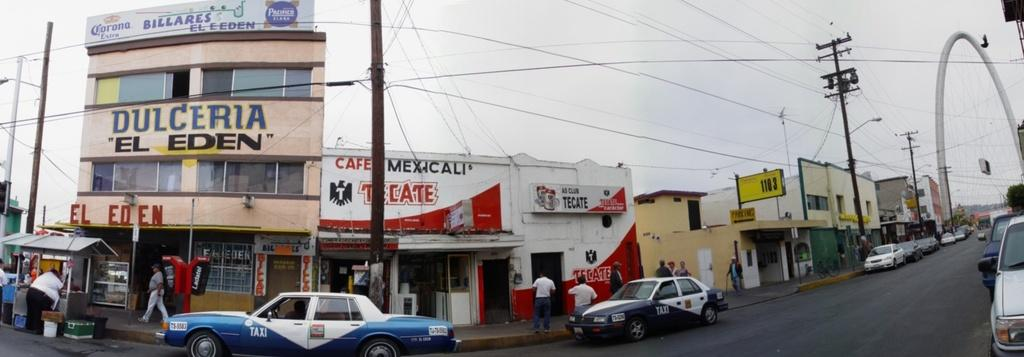<image>
Render a clear and concise summary of the photo. the word dulceria is on the sign above the street 